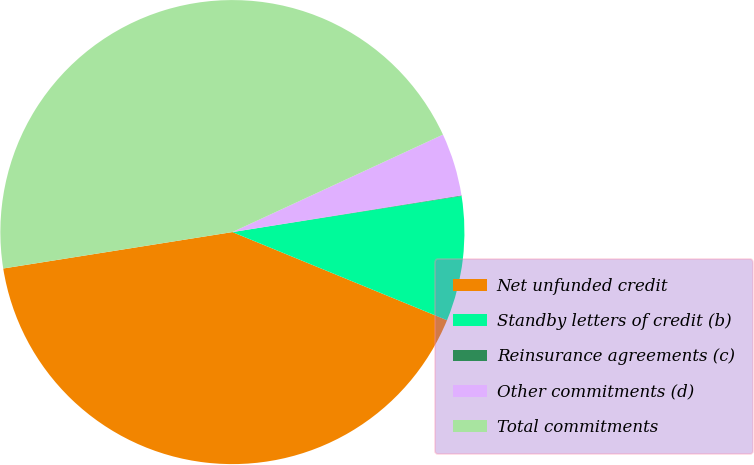Convert chart. <chart><loc_0><loc_0><loc_500><loc_500><pie_chart><fcel>Net unfunded credit<fcel>Standby letters of credit (b)<fcel>Reinsurance agreements (c)<fcel>Other commitments (d)<fcel>Total commitments<nl><fcel>41.29%<fcel>8.69%<fcel>0.04%<fcel>4.37%<fcel>45.61%<nl></chart> 